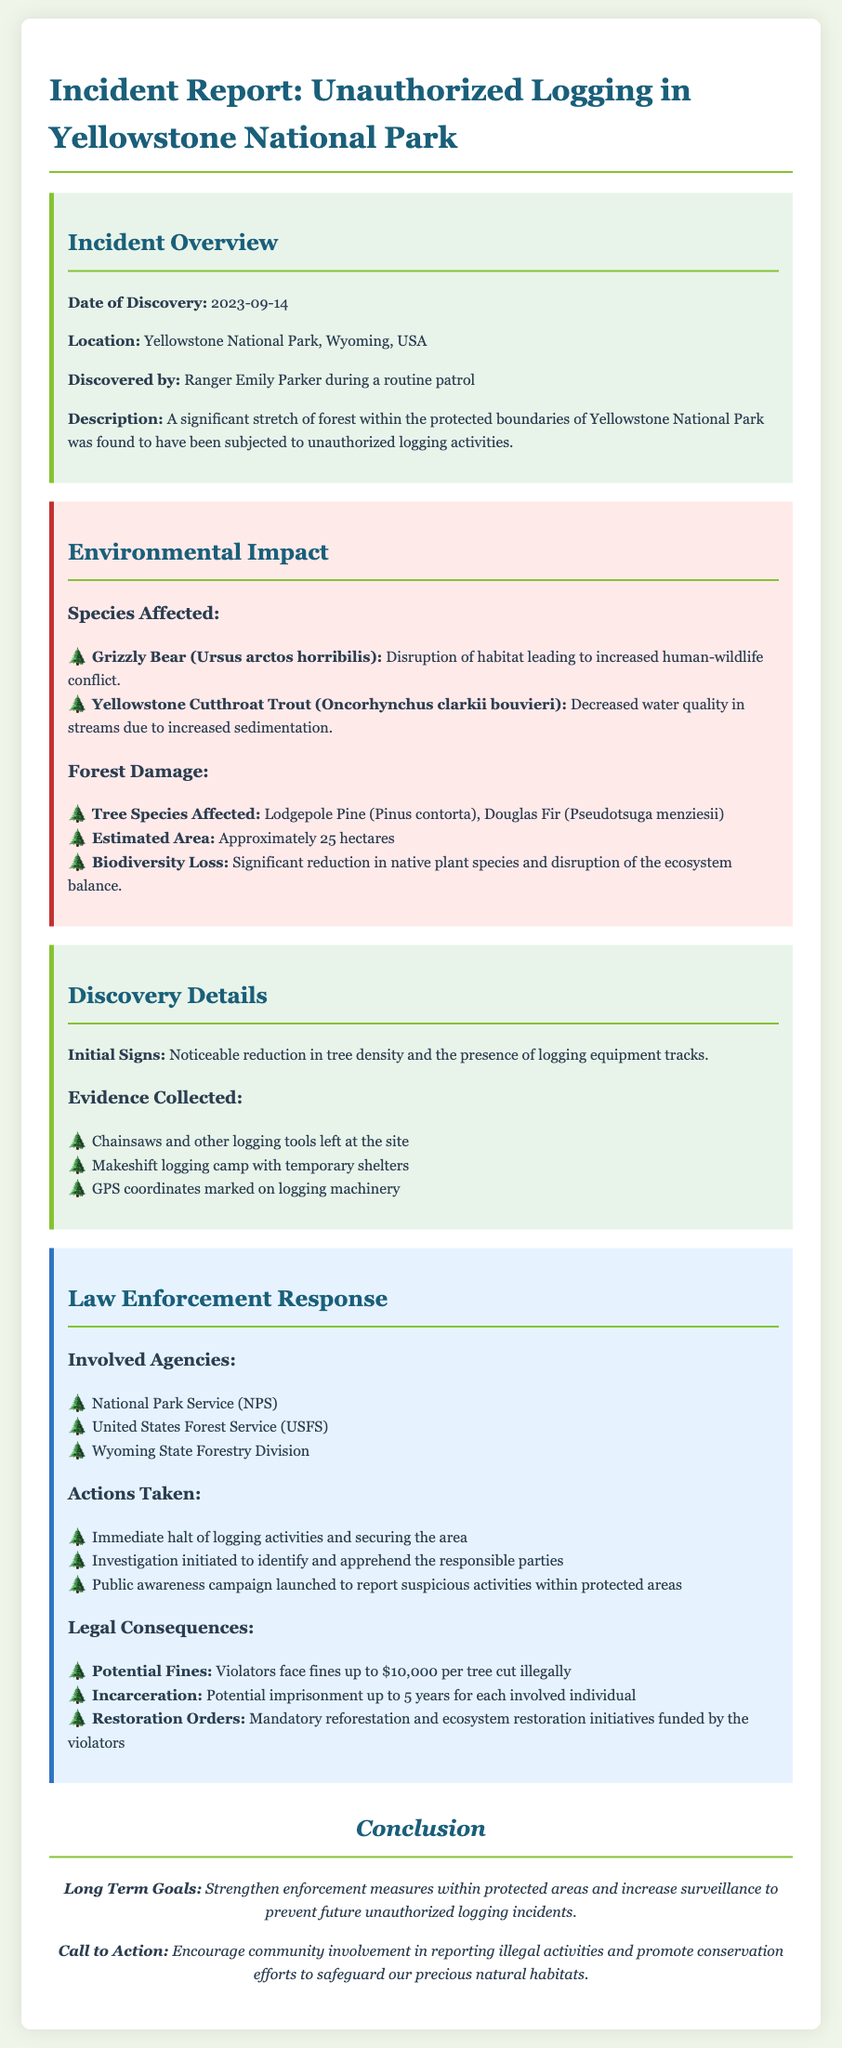What was the date of discovery? The date of discovery is provided in the incident report.
Answer: 2023-09-14 Who discovered the unauthorized logging? The report mentions who discovered the incident during a routine patrol.
Answer: Ranger Emily Parker What was the estimated area of forest damaged? The document contains an estimate of the area affected by logging.
Answer: Approximately 25 hectares Which species experienced habitat disruption? The report lists species affected due to logging activities.
Answer: Grizzly Bear What actions were taken by law enforcement? The report details various actions taken in response to the incident.
Answer: Immediate halt of logging activities and securing the area How many years of imprisonment could violators face? The document specifies potential consequences for violators, including imprisonment.
Answer: Up to 5 years What type of tools were left at the logging site? The findings at the logging site include specific tools mentioned in the report.
Answer: Chainsaws and other logging tools Which agency was involved in the investigation? The report lists multiple agencies involved in the law enforcement response.
Answer: National Park Service (NPS) 